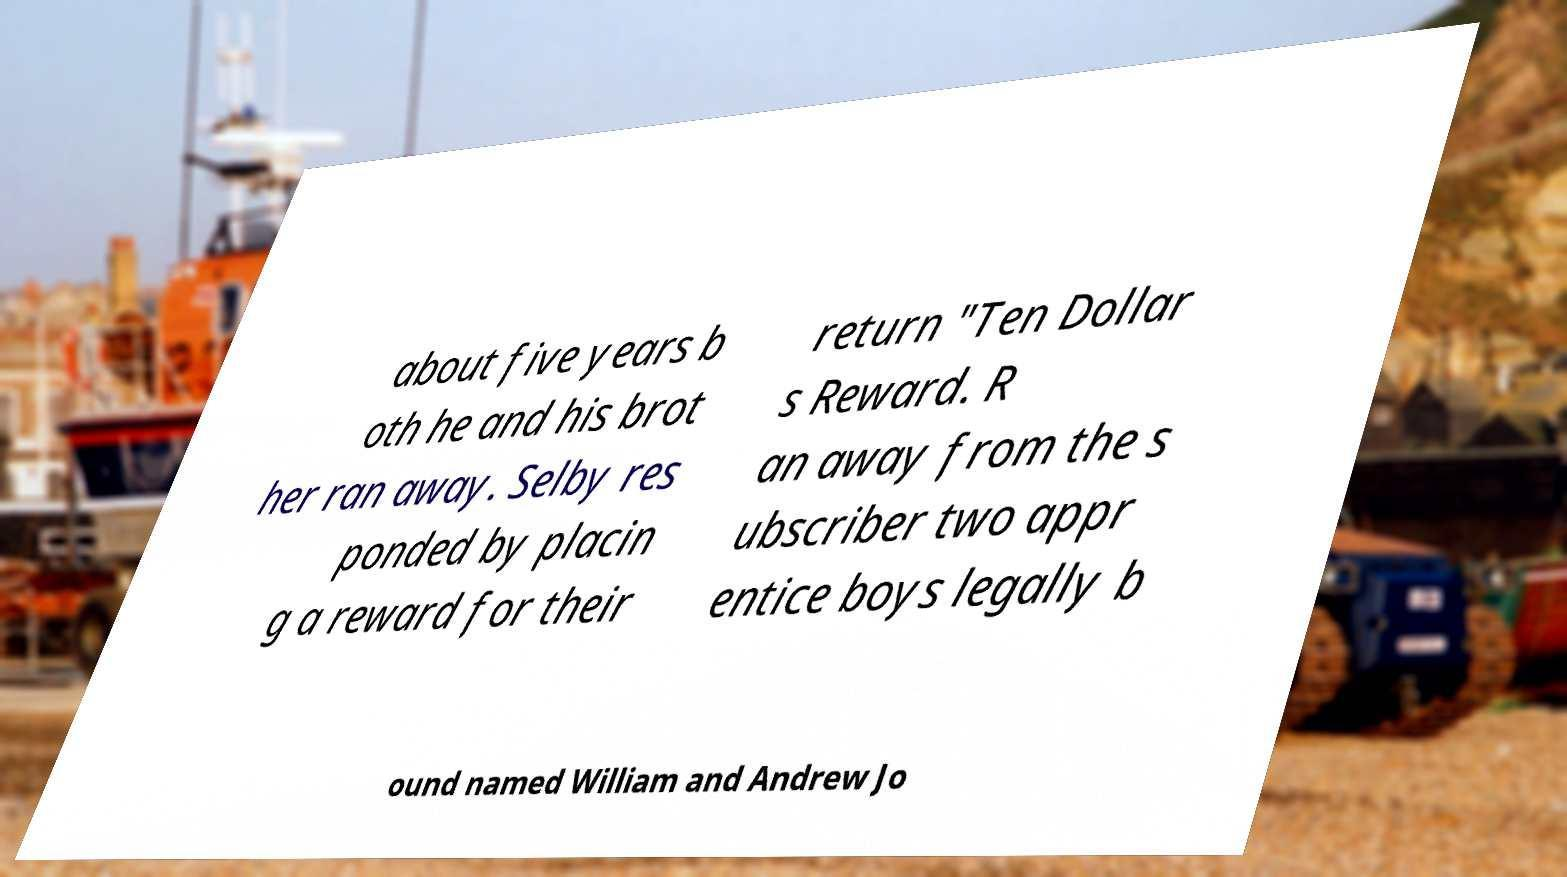Could you assist in decoding the text presented in this image and type it out clearly? about five years b oth he and his brot her ran away. Selby res ponded by placin g a reward for their return "Ten Dollar s Reward. R an away from the s ubscriber two appr entice boys legally b ound named William and Andrew Jo 